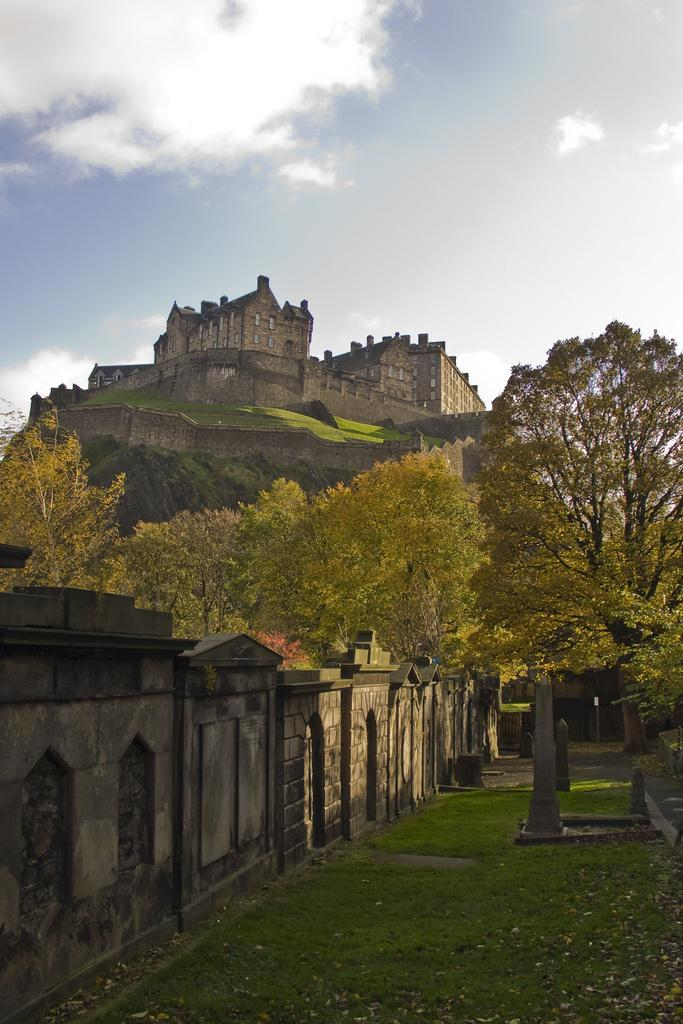What type of vegetation is present in the foreground of the image? There are trees in the foreground of the image. What else can be seen in the foreground of the image besides trees? There is grassland and a wall in the foreground of the image. What type of structure is depicted in the image? The image appears to depict a castle. What can be seen in the background of the image? The sky is visible in the background of the image. What type of treatment is being administered to the oven in the image? There is no oven present in the image, so no treatment can be administered. What order is being followed by the people in the image? There are no people present in the image, so no order can be followed. 